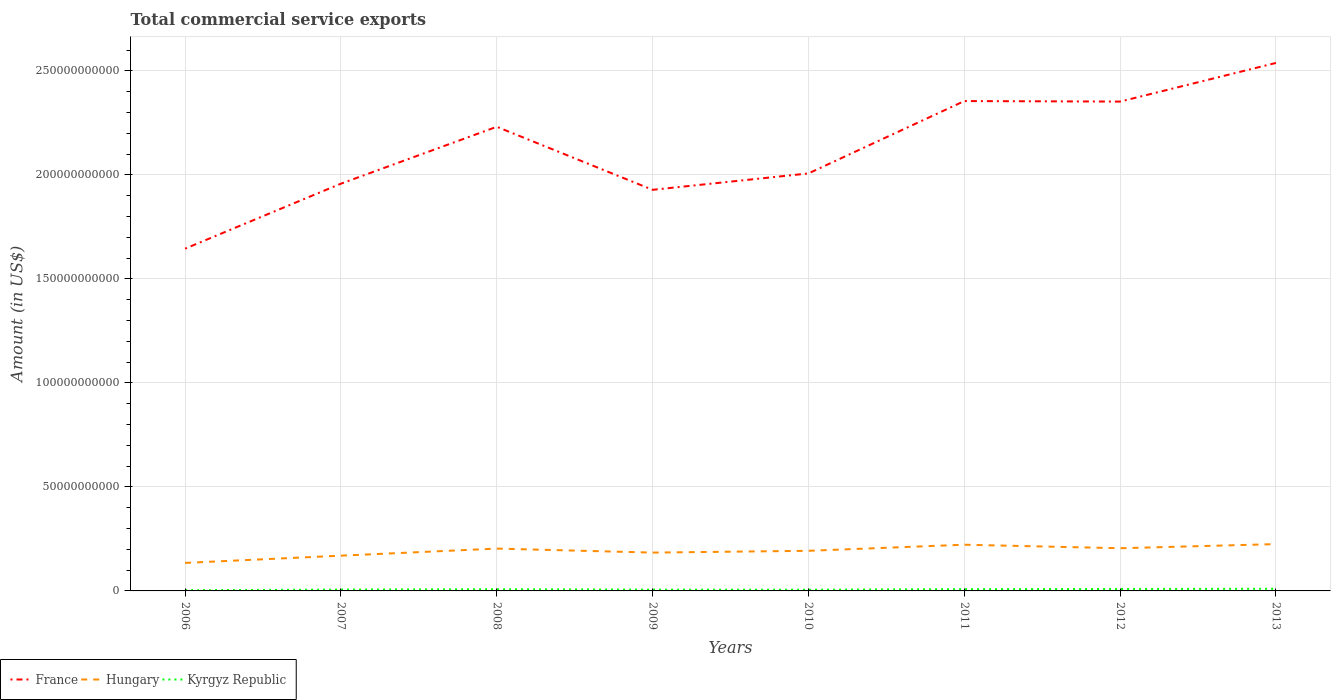Across all years, what is the maximum total commercial service exports in Hungary?
Give a very brief answer. 1.35e+1. What is the total total commercial service exports in Kyrgyz Republic in the graph?
Your answer should be compact. -3.23e+08. What is the difference between the highest and the second highest total commercial service exports in France?
Your answer should be very brief. 8.93e+1. How many years are there in the graph?
Make the answer very short. 8. What is the difference between two consecutive major ticks on the Y-axis?
Your answer should be very brief. 5.00e+1. Does the graph contain grids?
Keep it short and to the point. Yes. Where does the legend appear in the graph?
Offer a terse response. Bottom left. How many legend labels are there?
Your answer should be very brief. 3. How are the legend labels stacked?
Give a very brief answer. Horizontal. What is the title of the graph?
Your answer should be compact. Total commercial service exports. What is the label or title of the Y-axis?
Make the answer very short. Amount (in US$). What is the Amount (in US$) of France in 2006?
Offer a terse response. 1.65e+11. What is the Amount (in US$) in Hungary in 2006?
Ensure brevity in your answer.  1.35e+1. What is the Amount (in US$) of Kyrgyz Republic in 2006?
Your response must be concise. 3.51e+08. What is the Amount (in US$) in France in 2007?
Give a very brief answer. 1.96e+11. What is the Amount (in US$) in Hungary in 2007?
Keep it short and to the point. 1.69e+1. What is the Amount (in US$) in Kyrgyz Republic in 2007?
Provide a succinct answer. 6.54e+08. What is the Amount (in US$) of France in 2008?
Ensure brevity in your answer.  2.23e+11. What is the Amount (in US$) of Hungary in 2008?
Keep it short and to the point. 2.04e+1. What is the Amount (in US$) in Kyrgyz Republic in 2008?
Provide a short and direct response. 7.95e+08. What is the Amount (in US$) of France in 2009?
Provide a short and direct response. 1.93e+11. What is the Amount (in US$) in Hungary in 2009?
Give a very brief answer. 1.84e+1. What is the Amount (in US$) in Kyrgyz Republic in 2009?
Offer a very short reply. 6.28e+08. What is the Amount (in US$) of France in 2010?
Give a very brief answer. 2.01e+11. What is the Amount (in US$) of Hungary in 2010?
Make the answer very short. 1.93e+1. What is the Amount (in US$) in Kyrgyz Republic in 2010?
Keep it short and to the point. 5.86e+08. What is the Amount (in US$) of France in 2011?
Your response must be concise. 2.35e+11. What is the Amount (in US$) of Hungary in 2011?
Make the answer very short. 2.22e+1. What is the Amount (in US$) of Kyrgyz Republic in 2011?
Keep it short and to the point. 8.46e+08. What is the Amount (in US$) in France in 2012?
Give a very brief answer. 2.35e+11. What is the Amount (in US$) of Hungary in 2012?
Your response must be concise. 2.05e+1. What is the Amount (in US$) in Kyrgyz Republic in 2012?
Offer a very short reply. 9.51e+08. What is the Amount (in US$) of France in 2013?
Give a very brief answer. 2.54e+11. What is the Amount (in US$) of Hungary in 2013?
Your answer should be compact. 2.25e+1. What is the Amount (in US$) in Kyrgyz Republic in 2013?
Make the answer very short. 1.03e+09. Across all years, what is the maximum Amount (in US$) in France?
Offer a terse response. 2.54e+11. Across all years, what is the maximum Amount (in US$) in Hungary?
Your response must be concise. 2.25e+1. Across all years, what is the maximum Amount (in US$) of Kyrgyz Republic?
Provide a short and direct response. 1.03e+09. Across all years, what is the minimum Amount (in US$) in France?
Give a very brief answer. 1.65e+11. Across all years, what is the minimum Amount (in US$) in Hungary?
Keep it short and to the point. 1.35e+1. Across all years, what is the minimum Amount (in US$) in Kyrgyz Republic?
Offer a terse response. 3.51e+08. What is the total Amount (in US$) of France in the graph?
Your response must be concise. 1.70e+12. What is the total Amount (in US$) in Hungary in the graph?
Your answer should be very brief. 1.54e+11. What is the total Amount (in US$) of Kyrgyz Republic in the graph?
Provide a short and direct response. 5.84e+09. What is the difference between the Amount (in US$) of France in 2006 and that in 2007?
Keep it short and to the point. -3.12e+1. What is the difference between the Amount (in US$) of Hungary in 2006 and that in 2007?
Provide a succinct answer. -3.48e+09. What is the difference between the Amount (in US$) of Kyrgyz Republic in 2006 and that in 2007?
Your answer should be very brief. -3.03e+08. What is the difference between the Amount (in US$) of France in 2006 and that in 2008?
Keep it short and to the point. -5.86e+1. What is the difference between the Amount (in US$) in Hungary in 2006 and that in 2008?
Provide a short and direct response. -6.88e+09. What is the difference between the Amount (in US$) in Kyrgyz Republic in 2006 and that in 2008?
Make the answer very short. -4.43e+08. What is the difference between the Amount (in US$) in France in 2006 and that in 2009?
Your answer should be very brief. -2.83e+1. What is the difference between the Amount (in US$) in Hungary in 2006 and that in 2009?
Your response must be concise. -4.96e+09. What is the difference between the Amount (in US$) of Kyrgyz Republic in 2006 and that in 2009?
Your answer should be compact. -2.76e+08. What is the difference between the Amount (in US$) of France in 2006 and that in 2010?
Provide a succinct answer. -3.62e+1. What is the difference between the Amount (in US$) of Hungary in 2006 and that in 2010?
Offer a terse response. -5.82e+09. What is the difference between the Amount (in US$) of Kyrgyz Republic in 2006 and that in 2010?
Offer a very short reply. -2.34e+08. What is the difference between the Amount (in US$) of France in 2006 and that in 2011?
Offer a very short reply. -7.10e+1. What is the difference between the Amount (in US$) of Hungary in 2006 and that in 2011?
Offer a very short reply. -8.74e+09. What is the difference between the Amount (in US$) of Kyrgyz Republic in 2006 and that in 2011?
Offer a terse response. -4.95e+08. What is the difference between the Amount (in US$) in France in 2006 and that in 2012?
Ensure brevity in your answer.  -7.07e+1. What is the difference between the Amount (in US$) of Hungary in 2006 and that in 2012?
Make the answer very short. -7.05e+09. What is the difference between the Amount (in US$) of Kyrgyz Republic in 2006 and that in 2012?
Offer a very short reply. -6.00e+08. What is the difference between the Amount (in US$) in France in 2006 and that in 2013?
Offer a very short reply. -8.93e+1. What is the difference between the Amount (in US$) in Hungary in 2006 and that in 2013?
Offer a very short reply. -9.03e+09. What is the difference between the Amount (in US$) of Kyrgyz Republic in 2006 and that in 2013?
Offer a very short reply. -6.76e+08. What is the difference between the Amount (in US$) of France in 2007 and that in 2008?
Provide a short and direct response. -2.73e+1. What is the difference between the Amount (in US$) in Hungary in 2007 and that in 2008?
Ensure brevity in your answer.  -3.40e+09. What is the difference between the Amount (in US$) in Kyrgyz Republic in 2007 and that in 2008?
Offer a terse response. -1.41e+08. What is the difference between the Amount (in US$) of France in 2007 and that in 2009?
Offer a terse response. 2.96e+09. What is the difference between the Amount (in US$) of Hungary in 2007 and that in 2009?
Your answer should be very brief. -1.48e+09. What is the difference between the Amount (in US$) in Kyrgyz Republic in 2007 and that in 2009?
Ensure brevity in your answer.  2.61e+07. What is the difference between the Amount (in US$) in France in 2007 and that in 2010?
Offer a very short reply. -4.92e+09. What is the difference between the Amount (in US$) in Hungary in 2007 and that in 2010?
Your response must be concise. -2.34e+09. What is the difference between the Amount (in US$) of Kyrgyz Republic in 2007 and that in 2010?
Give a very brief answer. 6.85e+07. What is the difference between the Amount (in US$) in France in 2007 and that in 2011?
Offer a very short reply. -3.97e+1. What is the difference between the Amount (in US$) in Hungary in 2007 and that in 2011?
Your response must be concise. -5.27e+09. What is the difference between the Amount (in US$) in Kyrgyz Republic in 2007 and that in 2011?
Make the answer very short. -1.92e+08. What is the difference between the Amount (in US$) of France in 2007 and that in 2012?
Keep it short and to the point. -3.95e+1. What is the difference between the Amount (in US$) in Hungary in 2007 and that in 2012?
Your answer should be compact. -3.57e+09. What is the difference between the Amount (in US$) of Kyrgyz Republic in 2007 and that in 2012?
Your answer should be very brief. -2.97e+08. What is the difference between the Amount (in US$) of France in 2007 and that in 2013?
Ensure brevity in your answer.  -5.80e+1. What is the difference between the Amount (in US$) in Hungary in 2007 and that in 2013?
Provide a succinct answer. -5.56e+09. What is the difference between the Amount (in US$) of Kyrgyz Republic in 2007 and that in 2013?
Give a very brief answer. -3.73e+08. What is the difference between the Amount (in US$) of France in 2008 and that in 2009?
Offer a terse response. 3.03e+1. What is the difference between the Amount (in US$) of Hungary in 2008 and that in 2009?
Your response must be concise. 1.92e+09. What is the difference between the Amount (in US$) in Kyrgyz Republic in 2008 and that in 2009?
Ensure brevity in your answer.  1.67e+08. What is the difference between the Amount (in US$) in France in 2008 and that in 2010?
Make the answer very short. 2.24e+1. What is the difference between the Amount (in US$) in Hungary in 2008 and that in 2010?
Your answer should be very brief. 1.06e+09. What is the difference between the Amount (in US$) of Kyrgyz Republic in 2008 and that in 2010?
Offer a terse response. 2.09e+08. What is the difference between the Amount (in US$) in France in 2008 and that in 2011?
Make the answer very short. -1.24e+1. What is the difference between the Amount (in US$) in Hungary in 2008 and that in 2011?
Keep it short and to the point. -1.86e+09. What is the difference between the Amount (in US$) of Kyrgyz Republic in 2008 and that in 2011?
Keep it short and to the point. -5.12e+07. What is the difference between the Amount (in US$) in France in 2008 and that in 2012?
Offer a terse response. -1.21e+1. What is the difference between the Amount (in US$) in Hungary in 2008 and that in 2012?
Your answer should be very brief. -1.68e+08. What is the difference between the Amount (in US$) in Kyrgyz Republic in 2008 and that in 2012?
Keep it short and to the point. -1.56e+08. What is the difference between the Amount (in US$) of France in 2008 and that in 2013?
Offer a very short reply. -3.07e+1. What is the difference between the Amount (in US$) in Hungary in 2008 and that in 2013?
Give a very brief answer. -2.15e+09. What is the difference between the Amount (in US$) in Kyrgyz Republic in 2008 and that in 2013?
Give a very brief answer. -2.32e+08. What is the difference between the Amount (in US$) in France in 2009 and that in 2010?
Ensure brevity in your answer.  -7.88e+09. What is the difference between the Amount (in US$) in Hungary in 2009 and that in 2010?
Provide a short and direct response. -8.60e+08. What is the difference between the Amount (in US$) in Kyrgyz Republic in 2009 and that in 2010?
Your response must be concise. 4.24e+07. What is the difference between the Amount (in US$) of France in 2009 and that in 2011?
Ensure brevity in your answer.  -4.27e+1. What is the difference between the Amount (in US$) of Hungary in 2009 and that in 2011?
Provide a short and direct response. -3.79e+09. What is the difference between the Amount (in US$) of Kyrgyz Republic in 2009 and that in 2011?
Keep it short and to the point. -2.18e+08. What is the difference between the Amount (in US$) of France in 2009 and that in 2012?
Offer a very short reply. -4.24e+1. What is the difference between the Amount (in US$) of Hungary in 2009 and that in 2012?
Provide a short and direct response. -2.09e+09. What is the difference between the Amount (in US$) of Kyrgyz Republic in 2009 and that in 2012?
Ensure brevity in your answer.  -3.23e+08. What is the difference between the Amount (in US$) of France in 2009 and that in 2013?
Make the answer very short. -6.10e+1. What is the difference between the Amount (in US$) in Hungary in 2009 and that in 2013?
Your response must be concise. -4.08e+09. What is the difference between the Amount (in US$) of Kyrgyz Republic in 2009 and that in 2013?
Your answer should be compact. -3.99e+08. What is the difference between the Amount (in US$) in France in 2010 and that in 2011?
Give a very brief answer. -3.48e+1. What is the difference between the Amount (in US$) of Hungary in 2010 and that in 2011?
Provide a short and direct response. -2.93e+09. What is the difference between the Amount (in US$) in Kyrgyz Republic in 2010 and that in 2011?
Your response must be concise. -2.61e+08. What is the difference between the Amount (in US$) in France in 2010 and that in 2012?
Offer a terse response. -3.45e+1. What is the difference between the Amount (in US$) in Hungary in 2010 and that in 2012?
Provide a short and direct response. -1.23e+09. What is the difference between the Amount (in US$) in Kyrgyz Republic in 2010 and that in 2012?
Your response must be concise. -3.65e+08. What is the difference between the Amount (in US$) of France in 2010 and that in 2013?
Your answer should be very brief. -5.31e+1. What is the difference between the Amount (in US$) in Hungary in 2010 and that in 2013?
Provide a short and direct response. -3.22e+09. What is the difference between the Amount (in US$) of Kyrgyz Republic in 2010 and that in 2013?
Provide a short and direct response. -4.42e+08. What is the difference between the Amount (in US$) of France in 2011 and that in 2012?
Your answer should be very brief. 2.47e+08. What is the difference between the Amount (in US$) in Hungary in 2011 and that in 2012?
Give a very brief answer. 1.69e+09. What is the difference between the Amount (in US$) of Kyrgyz Republic in 2011 and that in 2012?
Make the answer very short. -1.05e+08. What is the difference between the Amount (in US$) in France in 2011 and that in 2013?
Make the answer very short. -1.83e+1. What is the difference between the Amount (in US$) in Hungary in 2011 and that in 2013?
Offer a very short reply. -2.91e+08. What is the difference between the Amount (in US$) in Kyrgyz Republic in 2011 and that in 2013?
Provide a succinct answer. -1.81e+08. What is the difference between the Amount (in US$) of France in 2012 and that in 2013?
Provide a succinct answer. -1.86e+1. What is the difference between the Amount (in US$) in Hungary in 2012 and that in 2013?
Ensure brevity in your answer.  -1.99e+09. What is the difference between the Amount (in US$) in Kyrgyz Republic in 2012 and that in 2013?
Provide a succinct answer. -7.63e+07. What is the difference between the Amount (in US$) in France in 2006 and the Amount (in US$) in Hungary in 2007?
Ensure brevity in your answer.  1.48e+11. What is the difference between the Amount (in US$) in France in 2006 and the Amount (in US$) in Kyrgyz Republic in 2007?
Your answer should be compact. 1.64e+11. What is the difference between the Amount (in US$) of Hungary in 2006 and the Amount (in US$) of Kyrgyz Republic in 2007?
Offer a terse response. 1.28e+1. What is the difference between the Amount (in US$) in France in 2006 and the Amount (in US$) in Hungary in 2008?
Ensure brevity in your answer.  1.44e+11. What is the difference between the Amount (in US$) in France in 2006 and the Amount (in US$) in Kyrgyz Republic in 2008?
Provide a short and direct response. 1.64e+11. What is the difference between the Amount (in US$) of Hungary in 2006 and the Amount (in US$) of Kyrgyz Republic in 2008?
Offer a terse response. 1.27e+1. What is the difference between the Amount (in US$) in France in 2006 and the Amount (in US$) in Hungary in 2009?
Give a very brief answer. 1.46e+11. What is the difference between the Amount (in US$) of France in 2006 and the Amount (in US$) of Kyrgyz Republic in 2009?
Your response must be concise. 1.64e+11. What is the difference between the Amount (in US$) in Hungary in 2006 and the Amount (in US$) in Kyrgyz Republic in 2009?
Provide a succinct answer. 1.28e+1. What is the difference between the Amount (in US$) of France in 2006 and the Amount (in US$) of Hungary in 2010?
Keep it short and to the point. 1.45e+11. What is the difference between the Amount (in US$) of France in 2006 and the Amount (in US$) of Kyrgyz Republic in 2010?
Offer a terse response. 1.64e+11. What is the difference between the Amount (in US$) in Hungary in 2006 and the Amount (in US$) in Kyrgyz Republic in 2010?
Offer a very short reply. 1.29e+1. What is the difference between the Amount (in US$) of France in 2006 and the Amount (in US$) of Hungary in 2011?
Offer a very short reply. 1.42e+11. What is the difference between the Amount (in US$) in France in 2006 and the Amount (in US$) in Kyrgyz Republic in 2011?
Keep it short and to the point. 1.64e+11. What is the difference between the Amount (in US$) in Hungary in 2006 and the Amount (in US$) in Kyrgyz Republic in 2011?
Give a very brief answer. 1.26e+1. What is the difference between the Amount (in US$) of France in 2006 and the Amount (in US$) of Hungary in 2012?
Provide a succinct answer. 1.44e+11. What is the difference between the Amount (in US$) in France in 2006 and the Amount (in US$) in Kyrgyz Republic in 2012?
Provide a short and direct response. 1.64e+11. What is the difference between the Amount (in US$) of Hungary in 2006 and the Amount (in US$) of Kyrgyz Republic in 2012?
Give a very brief answer. 1.25e+1. What is the difference between the Amount (in US$) in France in 2006 and the Amount (in US$) in Hungary in 2013?
Your answer should be very brief. 1.42e+11. What is the difference between the Amount (in US$) of France in 2006 and the Amount (in US$) of Kyrgyz Republic in 2013?
Keep it short and to the point. 1.64e+11. What is the difference between the Amount (in US$) of Hungary in 2006 and the Amount (in US$) of Kyrgyz Republic in 2013?
Your answer should be compact. 1.24e+1. What is the difference between the Amount (in US$) of France in 2007 and the Amount (in US$) of Hungary in 2008?
Make the answer very short. 1.75e+11. What is the difference between the Amount (in US$) in France in 2007 and the Amount (in US$) in Kyrgyz Republic in 2008?
Offer a terse response. 1.95e+11. What is the difference between the Amount (in US$) in Hungary in 2007 and the Amount (in US$) in Kyrgyz Republic in 2008?
Ensure brevity in your answer.  1.62e+1. What is the difference between the Amount (in US$) in France in 2007 and the Amount (in US$) in Hungary in 2009?
Your answer should be compact. 1.77e+11. What is the difference between the Amount (in US$) of France in 2007 and the Amount (in US$) of Kyrgyz Republic in 2009?
Offer a very short reply. 1.95e+11. What is the difference between the Amount (in US$) of Hungary in 2007 and the Amount (in US$) of Kyrgyz Republic in 2009?
Offer a terse response. 1.63e+1. What is the difference between the Amount (in US$) of France in 2007 and the Amount (in US$) of Hungary in 2010?
Your response must be concise. 1.76e+11. What is the difference between the Amount (in US$) of France in 2007 and the Amount (in US$) of Kyrgyz Republic in 2010?
Your response must be concise. 1.95e+11. What is the difference between the Amount (in US$) of Hungary in 2007 and the Amount (in US$) of Kyrgyz Republic in 2010?
Make the answer very short. 1.64e+1. What is the difference between the Amount (in US$) of France in 2007 and the Amount (in US$) of Hungary in 2011?
Offer a very short reply. 1.74e+11. What is the difference between the Amount (in US$) in France in 2007 and the Amount (in US$) in Kyrgyz Republic in 2011?
Your response must be concise. 1.95e+11. What is the difference between the Amount (in US$) in Hungary in 2007 and the Amount (in US$) in Kyrgyz Republic in 2011?
Your answer should be very brief. 1.61e+1. What is the difference between the Amount (in US$) of France in 2007 and the Amount (in US$) of Hungary in 2012?
Provide a short and direct response. 1.75e+11. What is the difference between the Amount (in US$) of France in 2007 and the Amount (in US$) of Kyrgyz Republic in 2012?
Keep it short and to the point. 1.95e+11. What is the difference between the Amount (in US$) of Hungary in 2007 and the Amount (in US$) of Kyrgyz Republic in 2012?
Offer a very short reply. 1.60e+1. What is the difference between the Amount (in US$) of France in 2007 and the Amount (in US$) of Hungary in 2013?
Provide a short and direct response. 1.73e+11. What is the difference between the Amount (in US$) of France in 2007 and the Amount (in US$) of Kyrgyz Republic in 2013?
Give a very brief answer. 1.95e+11. What is the difference between the Amount (in US$) in Hungary in 2007 and the Amount (in US$) in Kyrgyz Republic in 2013?
Your answer should be very brief. 1.59e+1. What is the difference between the Amount (in US$) in France in 2008 and the Amount (in US$) in Hungary in 2009?
Offer a terse response. 2.05e+11. What is the difference between the Amount (in US$) of France in 2008 and the Amount (in US$) of Kyrgyz Republic in 2009?
Offer a terse response. 2.22e+11. What is the difference between the Amount (in US$) in Hungary in 2008 and the Amount (in US$) in Kyrgyz Republic in 2009?
Provide a short and direct response. 1.97e+1. What is the difference between the Amount (in US$) of France in 2008 and the Amount (in US$) of Hungary in 2010?
Offer a terse response. 2.04e+11. What is the difference between the Amount (in US$) in France in 2008 and the Amount (in US$) in Kyrgyz Republic in 2010?
Your answer should be very brief. 2.23e+11. What is the difference between the Amount (in US$) of Hungary in 2008 and the Amount (in US$) of Kyrgyz Republic in 2010?
Provide a succinct answer. 1.98e+1. What is the difference between the Amount (in US$) of France in 2008 and the Amount (in US$) of Hungary in 2011?
Offer a terse response. 2.01e+11. What is the difference between the Amount (in US$) of France in 2008 and the Amount (in US$) of Kyrgyz Republic in 2011?
Offer a terse response. 2.22e+11. What is the difference between the Amount (in US$) in Hungary in 2008 and the Amount (in US$) in Kyrgyz Republic in 2011?
Provide a short and direct response. 1.95e+1. What is the difference between the Amount (in US$) of France in 2008 and the Amount (in US$) of Hungary in 2012?
Provide a succinct answer. 2.03e+11. What is the difference between the Amount (in US$) of France in 2008 and the Amount (in US$) of Kyrgyz Republic in 2012?
Provide a succinct answer. 2.22e+11. What is the difference between the Amount (in US$) of Hungary in 2008 and the Amount (in US$) of Kyrgyz Republic in 2012?
Keep it short and to the point. 1.94e+1. What is the difference between the Amount (in US$) in France in 2008 and the Amount (in US$) in Hungary in 2013?
Your response must be concise. 2.01e+11. What is the difference between the Amount (in US$) of France in 2008 and the Amount (in US$) of Kyrgyz Republic in 2013?
Keep it short and to the point. 2.22e+11. What is the difference between the Amount (in US$) in Hungary in 2008 and the Amount (in US$) in Kyrgyz Republic in 2013?
Provide a succinct answer. 1.93e+1. What is the difference between the Amount (in US$) of France in 2009 and the Amount (in US$) of Hungary in 2010?
Make the answer very short. 1.74e+11. What is the difference between the Amount (in US$) of France in 2009 and the Amount (in US$) of Kyrgyz Republic in 2010?
Your response must be concise. 1.92e+11. What is the difference between the Amount (in US$) of Hungary in 2009 and the Amount (in US$) of Kyrgyz Republic in 2010?
Give a very brief answer. 1.78e+1. What is the difference between the Amount (in US$) in France in 2009 and the Amount (in US$) in Hungary in 2011?
Make the answer very short. 1.71e+11. What is the difference between the Amount (in US$) of France in 2009 and the Amount (in US$) of Kyrgyz Republic in 2011?
Your response must be concise. 1.92e+11. What is the difference between the Amount (in US$) in Hungary in 2009 and the Amount (in US$) in Kyrgyz Republic in 2011?
Ensure brevity in your answer.  1.76e+1. What is the difference between the Amount (in US$) of France in 2009 and the Amount (in US$) of Hungary in 2012?
Provide a short and direct response. 1.72e+11. What is the difference between the Amount (in US$) of France in 2009 and the Amount (in US$) of Kyrgyz Republic in 2012?
Offer a very short reply. 1.92e+11. What is the difference between the Amount (in US$) in Hungary in 2009 and the Amount (in US$) in Kyrgyz Republic in 2012?
Ensure brevity in your answer.  1.75e+1. What is the difference between the Amount (in US$) in France in 2009 and the Amount (in US$) in Hungary in 2013?
Your answer should be compact. 1.70e+11. What is the difference between the Amount (in US$) of France in 2009 and the Amount (in US$) of Kyrgyz Republic in 2013?
Provide a succinct answer. 1.92e+11. What is the difference between the Amount (in US$) of Hungary in 2009 and the Amount (in US$) of Kyrgyz Republic in 2013?
Your response must be concise. 1.74e+1. What is the difference between the Amount (in US$) of France in 2010 and the Amount (in US$) of Hungary in 2011?
Offer a very short reply. 1.78e+11. What is the difference between the Amount (in US$) in France in 2010 and the Amount (in US$) in Kyrgyz Republic in 2011?
Provide a succinct answer. 2.00e+11. What is the difference between the Amount (in US$) of Hungary in 2010 and the Amount (in US$) of Kyrgyz Republic in 2011?
Offer a terse response. 1.84e+1. What is the difference between the Amount (in US$) in France in 2010 and the Amount (in US$) in Hungary in 2012?
Provide a succinct answer. 1.80e+11. What is the difference between the Amount (in US$) in France in 2010 and the Amount (in US$) in Kyrgyz Republic in 2012?
Your response must be concise. 2.00e+11. What is the difference between the Amount (in US$) of Hungary in 2010 and the Amount (in US$) of Kyrgyz Republic in 2012?
Provide a succinct answer. 1.83e+1. What is the difference between the Amount (in US$) in France in 2010 and the Amount (in US$) in Hungary in 2013?
Make the answer very short. 1.78e+11. What is the difference between the Amount (in US$) in France in 2010 and the Amount (in US$) in Kyrgyz Republic in 2013?
Keep it short and to the point. 2.00e+11. What is the difference between the Amount (in US$) of Hungary in 2010 and the Amount (in US$) of Kyrgyz Republic in 2013?
Offer a very short reply. 1.83e+1. What is the difference between the Amount (in US$) of France in 2011 and the Amount (in US$) of Hungary in 2012?
Offer a terse response. 2.15e+11. What is the difference between the Amount (in US$) of France in 2011 and the Amount (in US$) of Kyrgyz Republic in 2012?
Make the answer very short. 2.35e+11. What is the difference between the Amount (in US$) in Hungary in 2011 and the Amount (in US$) in Kyrgyz Republic in 2012?
Your answer should be compact. 2.13e+1. What is the difference between the Amount (in US$) of France in 2011 and the Amount (in US$) of Hungary in 2013?
Your response must be concise. 2.13e+11. What is the difference between the Amount (in US$) in France in 2011 and the Amount (in US$) in Kyrgyz Republic in 2013?
Provide a succinct answer. 2.34e+11. What is the difference between the Amount (in US$) of Hungary in 2011 and the Amount (in US$) of Kyrgyz Republic in 2013?
Provide a short and direct response. 2.12e+1. What is the difference between the Amount (in US$) of France in 2012 and the Amount (in US$) of Hungary in 2013?
Provide a short and direct response. 2.13e+11. What is the difference between the Amount (in US$) of France in 2012 and the Amount (in US$) of Kyrgyz Republic in 2013?
Your response must be concise. 2.34e+11. What is the difference between the Amount (in US$) in Hungary in 2012 and the Amount (in US$) in Kyrgyz Republic in 2013?
Ensure brevity in your answer.  1.95e+1. What is the average Amount (in US$) of France per year?
Make the answer very short. 2.13e+11. What is the average Amount (in US$) of Hungary per year?
Keep it short and to the point. 1.92e+1. What is the average Amount (in US$) of Kyrgyz Republic per year?
Make the answer very short. 7.30e+08. In the year 2006, what is the difference between the Amount (in US$) of France and Amount (in US$) of Hungary?
Your answer should be compact. 1.51e+11. In the year 2006, what is the difference between the Amount (in US$) in France and Amount (in US$) in Kyrgyz Republic?
Ensure brevity in your answer.  1.64e+11. In the year 2006, what is the difference between the Amount (in US$) of Hungary and Amount (in US$) of Kyrgyz Republic?
Keep it short and to the point. 1.31e+1. In the year 2007, what is the difference between the Amount (in US$) in France and Amount (in US$) in Hungary?
Your answer should be compact. 1.79e+11. In the year 2007, what is the difference between the Amount (in US$) of France and Amount (in US$) of Kyrgyz Republic?
Ensure brevity in your answer.  1.95e+11. In the year 2007, what is the difference between the Amount (in US$) in Hungary and Amount (in US$) in Kyrgyz Republic?
Your answer should be compact. 1.63e+1. In the year 2008, what is the difference between the Amount (in US$) of France and Amount (in US$) of Hungary?
Give a very brief answer. 2.03e+11. In the year 2008, what is the difference between the Amount (in US$) in France and Amount (in US$) in Kyrgyz Republic?
Offer a very short reply. 2.22e+11. In the year 2008, what is the difference between the Amount (in US$) of Hungary and Amount (in US$) of Kyrgyz Republic?
Provide a succinct answer. 1.96e+1. In the year 2009, what is the difference between the Amount (in US$) of France and Amount (in US$) of Hungary?
Offer a terse response. 1.74e+11. In the year 2009, what is the difference between the Amount (in US$) of France and Amount (in US$) of Kyrgyz Republic?
Make the answer very short. 1.92e+11. In the year 2009, what is the difference between the Amount (in US$) in Hungary and Amount (in US$) in Kyrgyz Republic?
Your answer should be compact. 1.78e+1. In the year 2010, what is the difference between the Amount (in US$) in France and Amount (in US$) in Hungary?
Offer a terse response. 1.81e+11. In the year 2010, what is the difference between the Amount (in US$) of France and Amount (in US$) of Kyrgyz Republic?
Provide a short and direct response. 2.00e+11. In the year 2010, what is the difference between the Amount (in US$) in Hungary and Amount (in US$) in Kyrgyz Republic?
Your answer should be compact. 1.87e+1. In the year 2011, what is the difference between the Amount (in US$) in France and Amount (in US$) in Hungary?
Offer a very short reply. 2.13e+11. In the year 2011, what is the difference between the Amount (in US$) of France and Amount (in US$) of Kyrgyz Republic?
Provide a short and direct response. 2.35e+11. In the year 2011, what is the difference between the Amount (in US$) of Hungary and Amount (in US$) of Kyrgyz Republic?
Offer a very short reply. 2.14e+1. In the year 2012, what is the difference between the Amount (in US$) in France and Amount (in US$) in Hungary?
Your answer should be very brief. 2.15e+11. In the year 2012, what is the difference between the Amount (in US$) in France and Amount (in US$) in Kyrgyz Republic?
Offer a terse response. 2.34e+11. In the year 2012, what is the difference between the Amount (in US$) in Hungary and Amount (in US$) in Kyrgyz Republic?
Your response must be concise. 1.96e+1. In the year 2013, what is the difference between the Amount (in US$) of France and Amount (in US$) of Hungary?
Your response must be concise. 2.31e+11. In the year 2013, what is the difference between the Amount (in US$) in France and Amount (in US$) in Kyrgyz Republic?
Your answer should be very brief. 2.53e+11. In the year 2013, what is the difference between the Amount (in US$) of Hungary and Amount (in US$) of Kyrgyz Republic?
Your answer should be compact. 2.15e+1. What is the ratio of the Amount (in US$) of France in 2006 to that in 2007?
Keep it short and to the point. 0.84. What is the ratio of the Amount (in US$) in Hungary in 2006 to that in 2007?
Offer a terse response. 0.79. What is the ratio of the Amount (in US$) in Kyrgyz Republic in 2006 to that in 2007?
Give a very brief answer. 0.54. What is the ratio of the Amount (in US$) in France in 2006 to that in 2008?
Your answer should be very brief. 0.74. What is the ratio of the Amount (in US$) of Hungary in 2006 to that in 2008?
Provide a succinct answer. 0.66. What is the ratio of the Amount (in US$) of Kyrgyz Republic in 2006 to that in 2008?
Your answer should be compact. 0.44. What is the ratio of the Amount (in US$) in France in 2006 to that in 2009?
Your response must be concise. 0.85. What is the ratio of the Amount (in US$) of Hungary in 2006 to that in 2009?
Provide a short and direct response. 0.73. What is the ratio of the Amount (in US$) of Kyrgyz Republic in 2006 to that in 2009?
Keep it short and to the point. 0.56. What is the ratio of the Amount (in US$) in France in 2006 to that in 2010?
Your answer should be compact. 0.82. What is the ratio of the Amount (in US$) in Hungary in 2006 to that in 2010?
Your answer should be compact. 0.7. What is the ratio of the Amount (in US$) of Kyrgyz Republic in 2006 to that in 2010?
Your answer should be very brief. 0.6. What is the ratio of the Amount (in US$) in France in 2006 to that in 2011?
Give a very brief answer. 0.7. What is the ratio of the Amount (in US$) in Hungary in 2006 to that in 2011?
Keep it short and to the point. 0.61. What is the ratio of the Amount (in US$) in Kyrgyz Republic in 2006 to that in 2011?
Make the answer very short. 0.42. What is the ratio of the Amount (in US$) in France in 2006 to that in 2012?
Your response must be concise. 0.7. What is the ratio of the Amount (in US$) in Hungary in 2006 to that in 2012?
Offer a very short reply. 0.66. What is the ratio of the Amount (in US$) in Kyrgyz Republic in 2006 to that in 2012?
Your response must be concise. 0.37. What is the ratio of the Amount (in US$) of France in 2006 to that in 2013?
Your answer should be very brief. 0.65. What is the ratio of the Amount (in US$) of Hungary in 2006 to that in 2013?
Keep it short and to the point. 0.6. What is the ratio of the Amount (in US$) in Kyrgyz Republic in 2006 to that in 2013?
Make the answer very short. 0.34. What is the ratio of the Amount (in US$) of France in 2007 to that in 2008?
Your answer should be very brief. 0.88. What is the ratio of the Amount (in US$) in Hungary in 2007 to that in 2008?
Offer a terse response. 0.83. What is the ratio of the Amount (in US$) of Kyrgyz Republic in 2007 to that in 2008?
Your answer should be compact. 0.82. What is the ratio of the Amount (in US$) of France in 2007 to that in 2009?
Provide a succinct answer. 1.02. What is the ratio of the Amount (in US$) in Hungary in 2007 to that in 2009?
Your answer should be compact. 0.92. What is the ratio of the Amount (in US$) of Kyrgyz Republic in 2007 to that in 2009?
Your response must be concise. 1.04. What is the ratio of the Amount (in US$) in France in 2007 to that in 2010?
Offer a very short reply. 0.98. What is the ratio of the Amount (in US$) in Hungary in 2007 to that in 2010?
Make the answer very short. 0.88. What is the ratio of the Amount (in US$) in Kyrgyz Republic in 2007 to that in 2010?
Provide a short and direct response. 1.12. What is the ratio of the Amount (in US$) in France in 2007 to that in 2011?
Keep it short and to the point. 0.83. What is the ratio of the Amount (in US$) of Hungary in 2007 to that in 2011?
Provide a short and direct response. 0.76. What is the ratio of the Amount (in US$) in Kyrgyz Republic in 2007 to that in 2011?
Offer a very short reply. 0.77. What is the ratio of the Amount (in US$) of France in 2007 to that in 2012?
Provide a short and direct response. 0.83. What is the ratio of the Amount (in US$) in Hungary in 2007 to that in 2012?
Offer a very short reply. 0.83. What is the ratio of the Amount (in US$) in Kyrgyz Republic in 2007 to that in 2012?
Make the answer very short. 0.69. What is the ratio of the Amount (in US$) in France in 2007 to that in 2013?
Make the answer very short. 0.77. What is the ratio of the Amount (in US$) of Hungary in 2007 to that in 2013?
Ensure brevity in your answer.  0.75. What is the ratio of the Amount (in US$) of Kyrgyz Republic in 2007 to that in 2013?
Offer a terse response. 0.64. What is the ratio of the Amount (in US$) in France in 2008 to that in 2009?
Ensure brevity in your answer.  1.16. What is the ratio of the Amount (in US$) of Hungary in 2008 to that in 2009?
Your answer should be compact. 1.1. What is the ratio of the Amount (in US$) of Kyrgyz Republic in 2008 to that in 2009?
Your answer should be compact. 1.27. What is the ratio of the Amount (in US$) of France in 2008 to that in 2010?
Your answer should be compact. 1.11. What is the ratio of the Amount (in US$) in Hungary in 2008 to that in 2010?
Offer a terse response. 1.06. What is the ratio of the Amount (in US$) in Kyrgyz Republic in 2008 to that in 2010?
Your answer should be very brief. 1.36. What is the ratio of the Amount (in US$) of France in 2008 to that in 2011?
Keep it short and to the point. 0.95. What is the ratio of the Amount (in US$) in Hungary in 2008 to that in 2011?
Give a very brief answer. 0.92. What is the ratio of the Amount (in US$) in Kyrgyz Republic in 2008 to that in 2011?
Give a very brief answer. 0.94. What is the ratio of the Amount (in US$) of France in 2008 to that in 2012?
Provide a succinct answer. 0.95. What is the ratio of the Amount (in US$) in Hungary in 2008 to that in 2012?
Provide a succinct answer. 0.99. What is the ratio of the Amount (in US$) in Kyrgyz Republic in 2008 to that in 2012?
Your answer should be very brief. 0.84. What is the ratio of the Amount (in US$) in France in 2008 to that in 2013?
Offer a terse response. 0.88. What is the ratio of the Amount (in US$) of Hungary in 2008 to that in 2013?
Offer a terse response. 0.9. What is the ratio of the Amount (in US$) in Kyrgyz Republic in 2008 to that in 2013?
Keep it short and to the point. 0.77. What is the ratio of the Amount (in US$) of France in 2009 to that in 2010?
Provide a succinct answer. 0.96. What is the ratio of the Amount (in US$) of Hungary in 2009 to that in 2010?
Your response must be concise. 0.96. What is the ratio of the Amount (in US$) of Kyrgyz Republic in 2009 to that in 2010?
Ensure brevity in your answer.  1.07. What is the ratio of the Amount (in US$) in France in 2009 to that in 2011?
Offer a terse response. 0.82. What is the ratio of the Amount (in US$) in Hungary in 2009 to that in 2011?
Your response must be concise. 0.83. What is the ratio of the Amount (in US$) in Kyrgyz Republic in 2009 to that in 2011?
Keep it short and to the point. 0.74. What is the ratio of the Amount (in US$) in France in 2009 to that in 2012?
Provide a short and direct response. 0.82. What is the ratio of the Amount (in US$) of Hungary in 2009 to that in 2012?
Offer a terse response. 0.9. What is the ratio of the Amount (in US$) of Kyrgyz Republic in 2009 to that in 2012?
Ensure brevity in your answer.  0.66. What is the ratio of the Amount (in US$) of France in 2009 to that in 2013?
Give a very brief answer. 0.76. What is the ratio of the Amount (in US$) of Hungary in 2009 to that in 2013?
Your answer should be very brief. 0.82. What is the ratio of the Amount (in US$) of Kyrgyz Republic in 2009 to that in 2013?
Your response must be concise. 0.61. What is the ratio of the Amount (in US$) of France in 2010 to that in 2011?
Provide a short and direct response. 0.85. What is the ratio of the Amount (in US$) of Hungary in 2010 to that in 2011?
Keep it short and to the point. 0.87. What is the ratio of the Amount (in US$) of Kyrgyz Republic in 2010 to that in 2011?
Provide a succinct answer. 0.69. What is the ratio of the Amount (in US$) in France in 2010 to that in 2012?
Keep it short and to the point. 0.85. What is the ratio of the Amount (in US$) of Hungary in 2010 to that in 2012?
Your answer should be compact. 0.94. What is the ratio of the Amount (in US$) of Kyrgyz Republic in 2010 to that in 2012?
Make the answer very short. 0.62. What is the ratio of the Amount (in US$) in France in 2010 to that in 2013?
Your response must be concise. 0.79. What is the ratio of the Amount (in US$) of Hungary in 2010 to that in 2013?
Make the answer very short. 0.86. What is the ratio of the Amount (in US$) of Kyrgyz Republic in 2010 to that in 2013?
Your answer should be compact. 0.57. What is the ratio of the Amount (in US$) of France in 2011 to that in 2012?
Your answer should be very brief. 1. What is the ratio of the Amount (in US$) in Hungary in 2011 to that in 2012?
Keep it short and to the point. 1.08. What is the ratio of the Amount (in US$) in Kyrgyz Republic in 2011 to that in 2012?
Your response must be concise. 0.89. What is the ratio of the Amount (in US$) of France in 2011 to that in 2013?
Your response must be concise. 0.93. What is the ratio of the Amount (in US$) in Hungary in 2011 to that in 2013?
Provide a short and direct response. 0.99. What is the ratio of the Amount (in US$) of Kyrgyz Republic in 2011 to that in 2013?
Your response must be concise. 0.82. What is the ratio of the Amount (in US$) of France in 2012 to that in 2013?
Offer a terse response. 0.93. What is the ratio of the Amount (in US$) in Hungary in 2012 to that in 2013?
Make the answer very short. 0.91. What is the ratio of the Amount (in US$) of Kyrgyz Republic in 2012 to that in 2013?
Ensure brevity in your answer.  0.93. What is the difference between the highest and the second highest Amount (in US$) in France?
Provide a short and direct response. 1.83e+1. What is the difference between the highest and the second highest Amount (in US$) of Hungary?
Offer a terse response. 2.91e+08. What is the difference between the highest and the second highest Amount (in US$) of Kyrgyz Republic?
Your answer should be compact. 7.63e+07. What is the difference between the highest and the lowest Amount (in US$) of France?
Offer a very short reply. 8.93e+1. What is the difference between the highest and the lowest Amount (in US$) in Hungary?
Your answer should be compact. 9.03e+09. What is the difference between the highest and the lowest Amount (in US$) in Kyrgyz Republic?
Give a very brief answer. 6.76e+08. 